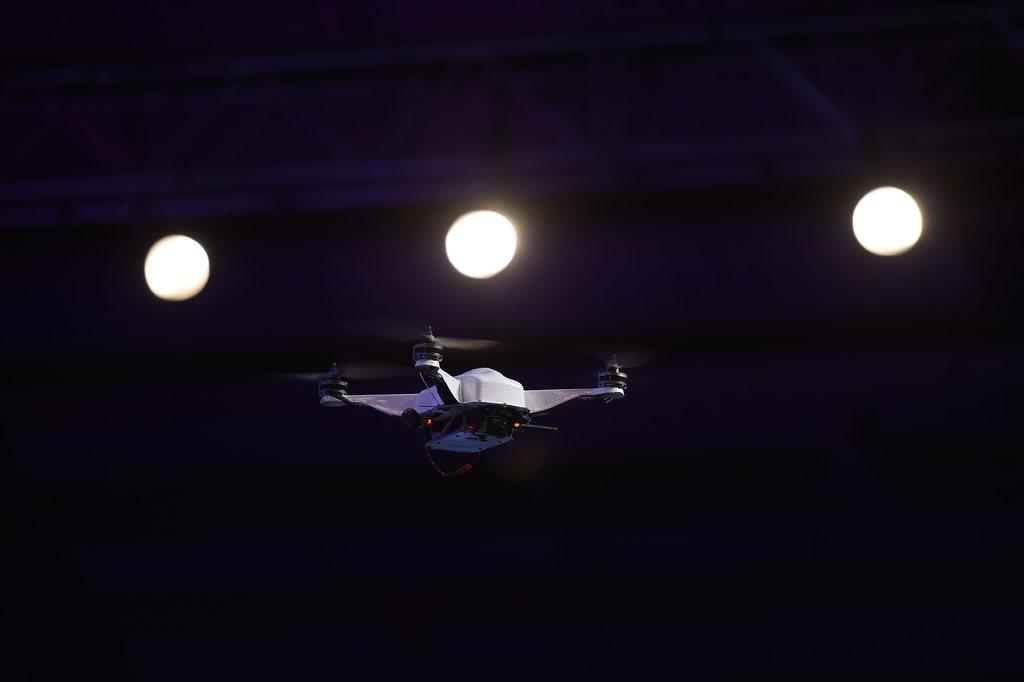What is the main subject of the image? The main subject of the image is a drone. Where is the drone located in the image? The drone is in the air in the image. What else can be seen in the image besides the drone? There are lights visible in the image. What type of gate is present in the image? There is no gate present in the image; it features a drone ine in the air and lights. 